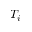Convert formula to latex. <formula><loc_0><loc_0><loc_500><loc_500>T _ { i }</formula> 